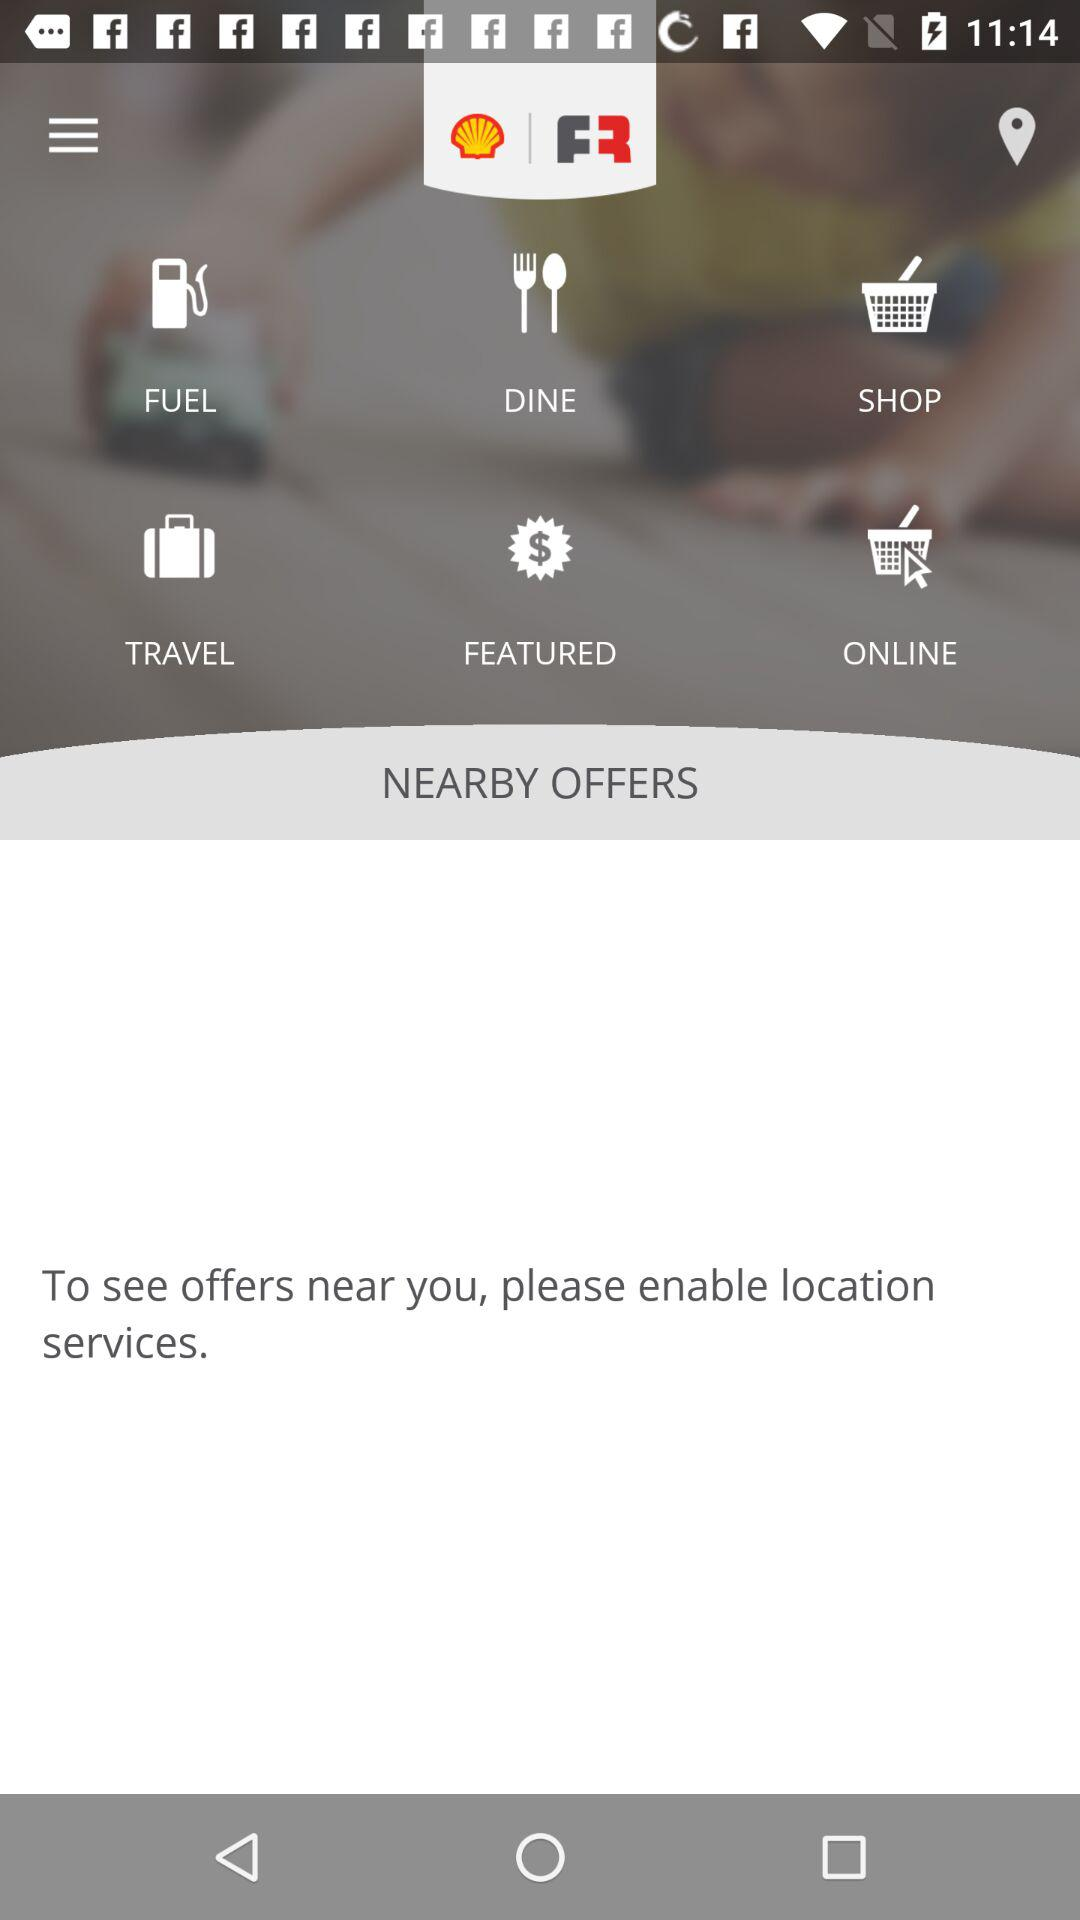What are the available options? The available options are "FUEL", "DINE", "SHOP", "TRAVEL", "FEATURED" and "ONLINE". 